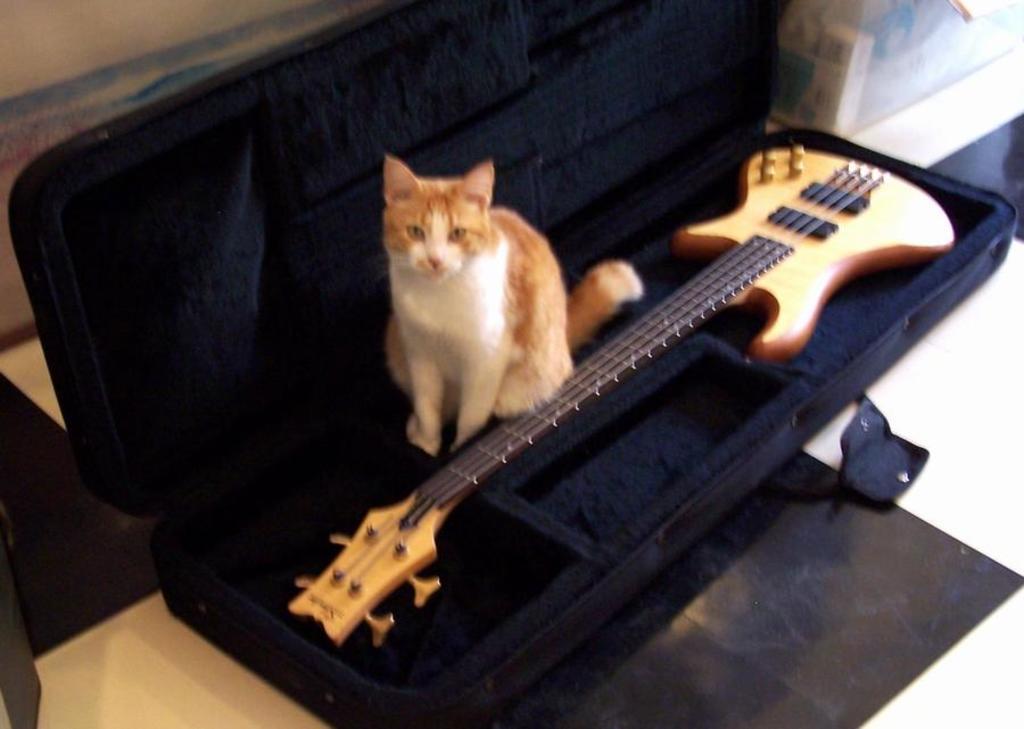How would you summarize this image in a sentence or two? In this picture we can see box and inside the box we have cat, guitar and in the background we can see wall. 